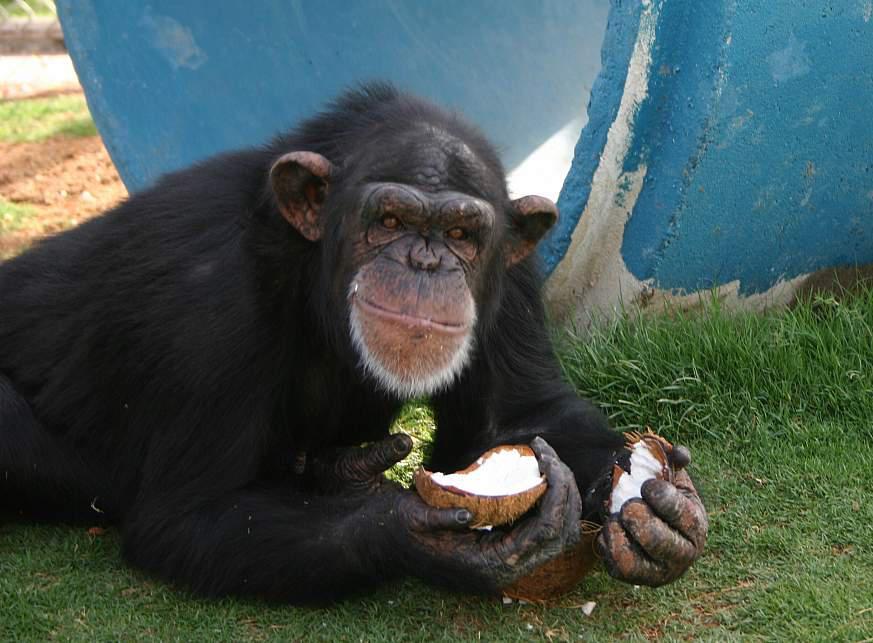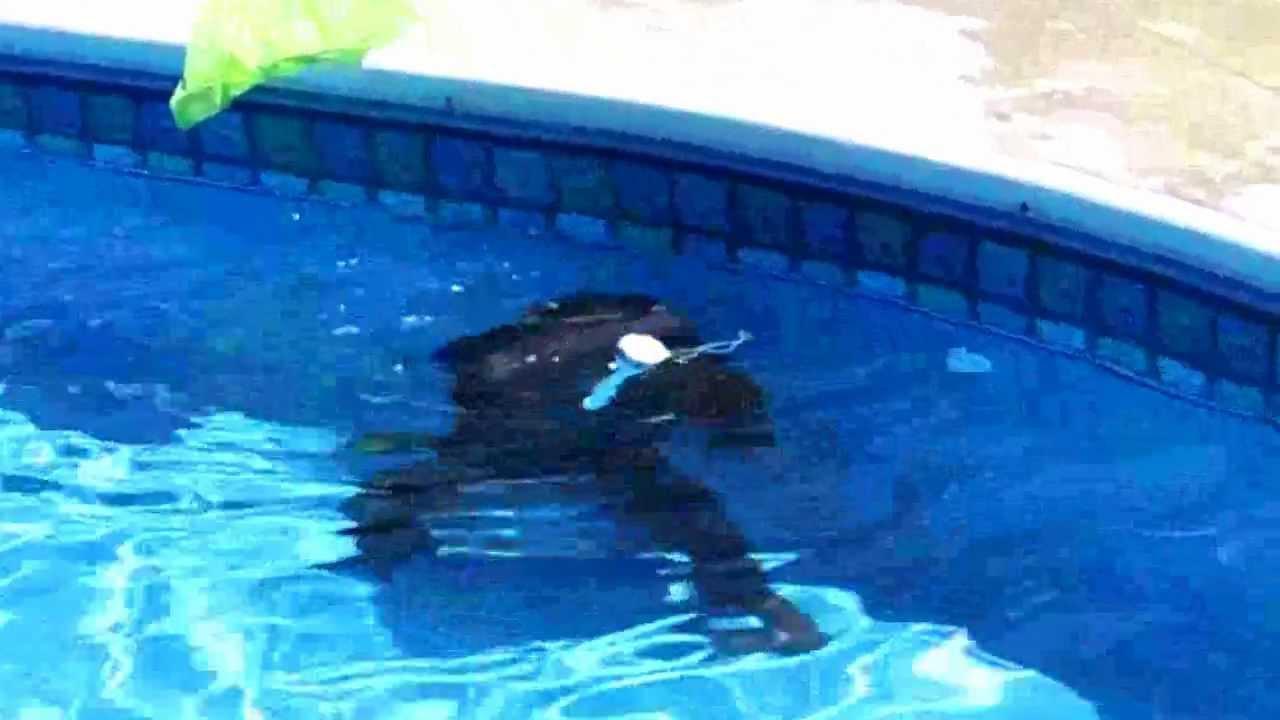The first image is the image on the left, the second image is the image on the right. Analyze the images presented: Is the assertion "One image shows no more than three chimps, who are near one another in a grassy field,  and the other image includes a chimp at the edge of a small pool sunken in the ground." valid? Answer yes or no. No. 